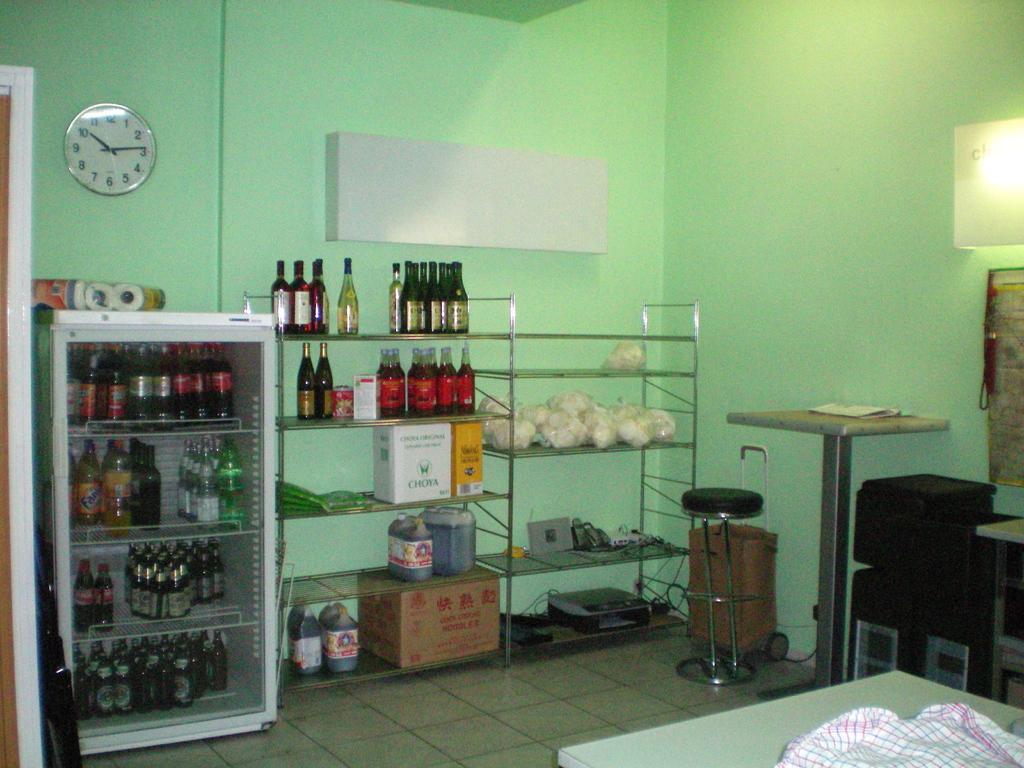Please provide a concise description of this image. In this picture I can see bottles in a refrigerator, there are bottles, cardboard boxes and some other items in and on the racks, there is a stool, there are tables and some other objects, there is a clock attached to the wall. 